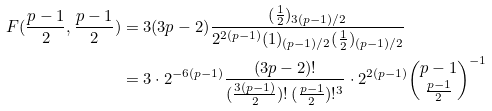<formula> <loc_0><loc_0><loc_500><loc_500>F ( \frac { p - 1 } 2 , \frac { p - 1 } 2 ) & = 3 ( 3 p - 2 ) \frac { ( \frac { 1 } { 2 } ) _ { 3 ( p - 1 ) / 2 } } { 2 ^ { 2 ( p - 1 ) } ( 1 ) _ { ( p - 1 ) / 2 } ( \frac { 1 } { 2 } ) _ { ( p - 1 ) / 2 } } \\ & = 3 \cdot 2 ^ { - 6 ( p - 1 ) } \frac { ( 3 p - 2 ) ! } { ( \frac { 3 ( p - 1 ) } 2 ) ! \, ( \frac { p - 1 } 2 ) ! ^ { 3 } } \cdot 2 ^ { 2 ( p - 1 ) } { \binom { p - 1 } { \frac { p - 1 } 2 } } ^ { - 1 }</formula> 